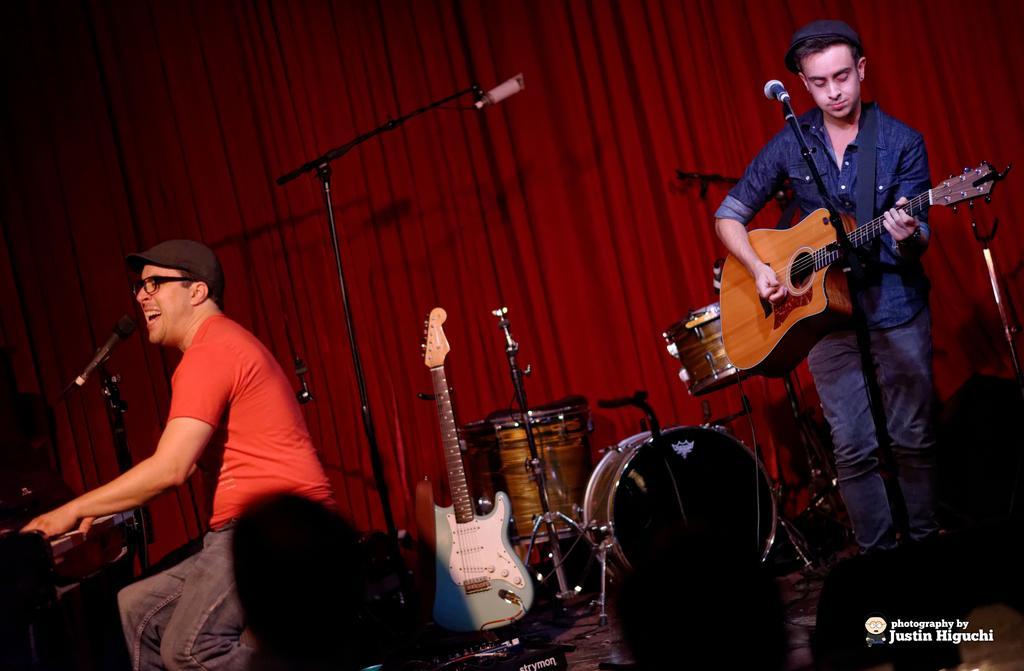Could you give a brief overview of what you see in this image? Here at the right we can see a man playing a guitar with a microphone in front of him and at the left we can see a man sitting on a chair playing a piano and between them there are other musical instruments and there is a curtain behind them 